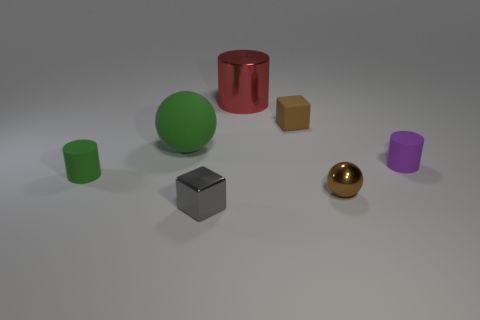Add 2 tiny red matte spheres. How many objects exist? 9 Subtract all balls. How many objects are left? 5 Add 4 big brown metallic cubes. How many big brown metallic cubes exist? 4 Subtract 0 brown cylinders. How many objects are left? 7 Subtract all small yellow things. Subtract all tiny brown rubber objects. How many objects are left? 6 Add 7 metallic objects. How many metallic objects are left? 10 